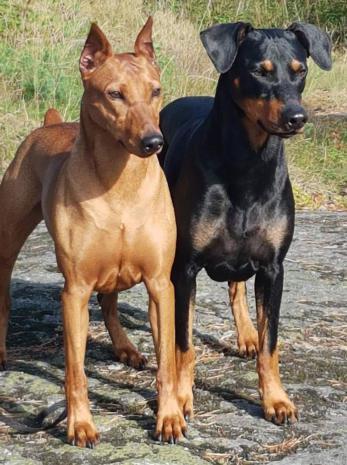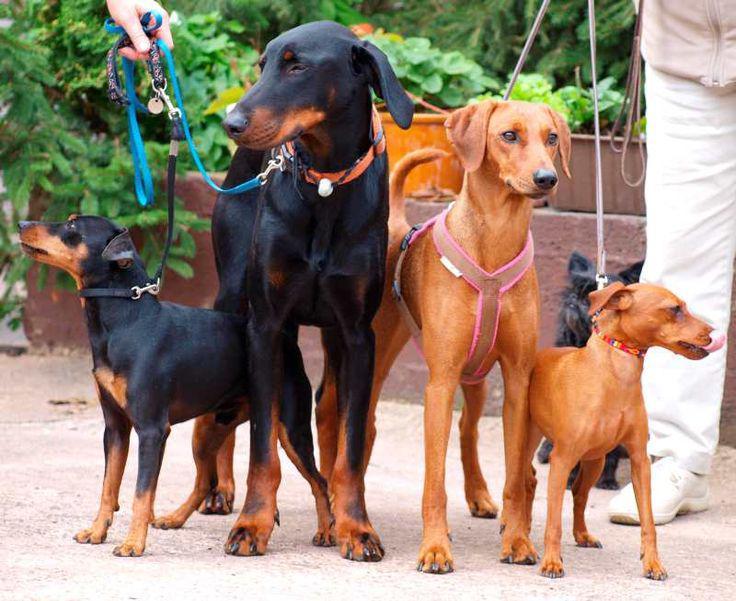The first image is the image on the left, the second image is the image on the right. For the images shown, is this caption "In the left image, two dogs are standing side-by-side, with their bodies and heads turned in the same direction." true? Answer yes or no. Yes. The first image is the image on the left, the second image is the image on the right. For the images shown, is this caption "The right image contains no more than two dogs." true? Answer yes or no. No. 